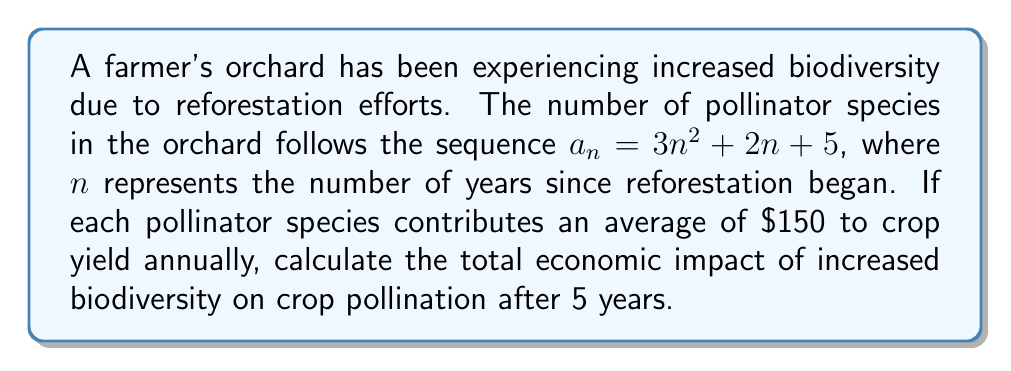Could you help me with this problem? To solve this problem, we'll follow these steps:

1) First, we need to find the number of pollinator species after 5 years:
   $a_5 = 3(5)^2 + 2(5) + 5$
   $a_5 = 3(25) + 10 + 5$
   $a_5 = 75 + 10 + 5$
   $a_5 = 90$ species

2) Now, we know that each species contributes $\$150$ annually to crop yield.
   To find the total economic impact, we multiply the number of species by the contribution per species:

   $\text{Total Impact} = 90 \times \$150 = \$13,500$

Therefore, the total economic impact of increased biodiversity on crop pollination after 5 years is $\$13,500$.
Answer: $\$13,500$ 